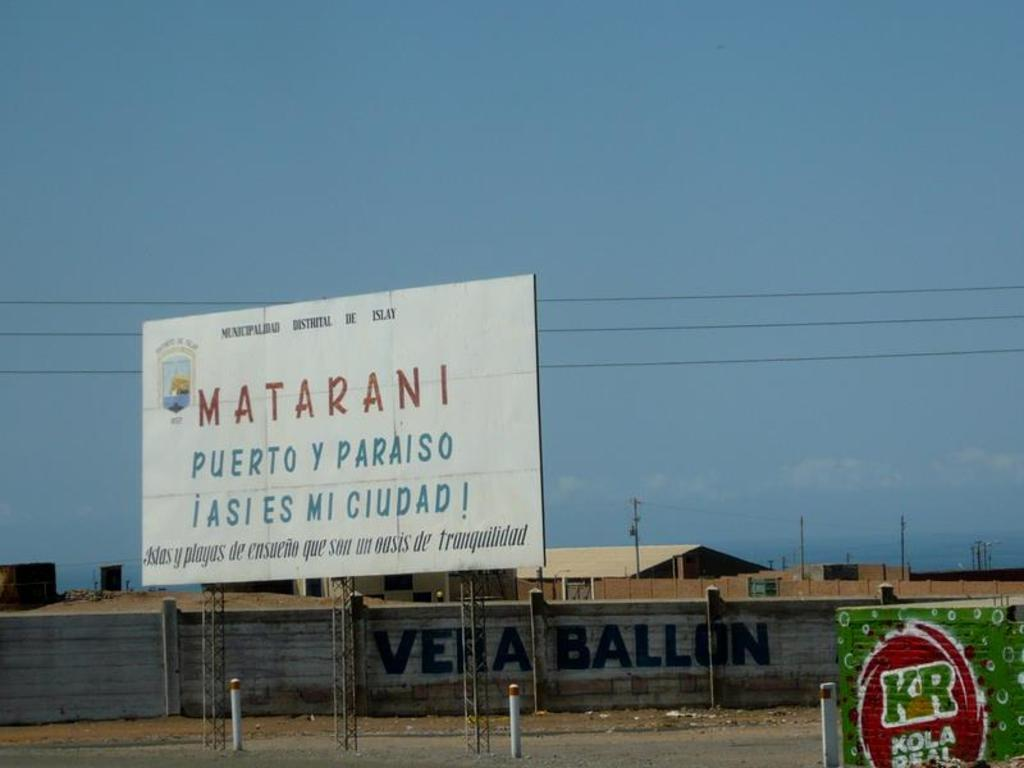<image>
Present a compact description of the photo's key features. a billboard for Matarani Puerto y Paraiso on the road side 